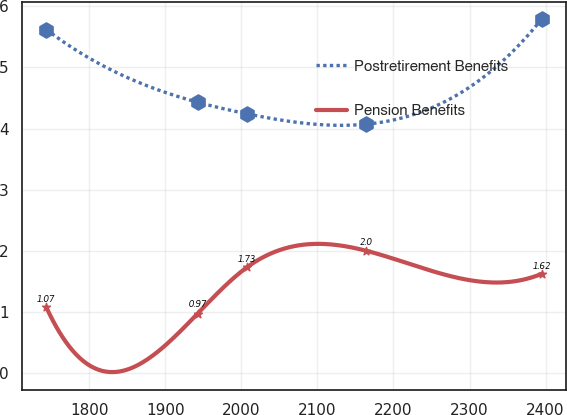Convert chart. <chart><loc_0><loc_0><loc_500><loc_500><line_chart><ecel><fcel>Postretirement Benefits<fcel>Pension Benefits<nl><fcel>1743.51<fcel>5.62<fcel>1.07<nl><fcel>1942.42<fcel>4.43<fcel>0.97<nl><fcel>2007.56<fcel>4.24<fcel>1.73<nl><fcel>2163.56<fcel>4.07<fcel>2<nl><fcel>2394.86<fcel>5.79<fcel>1.62<nl></chart> 